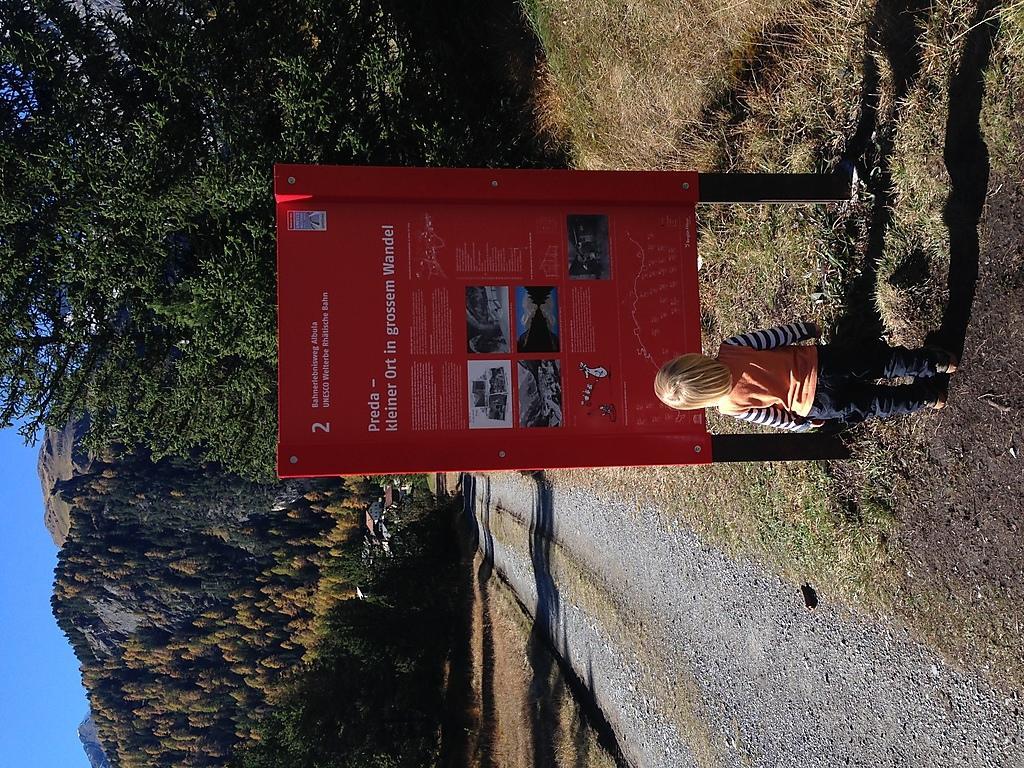Please provide a concise description of this image. This image consists of a small girl standing. In front of her there is a board in green color. At the bottom, there is green grass. To the left, there are trees and mountains. 